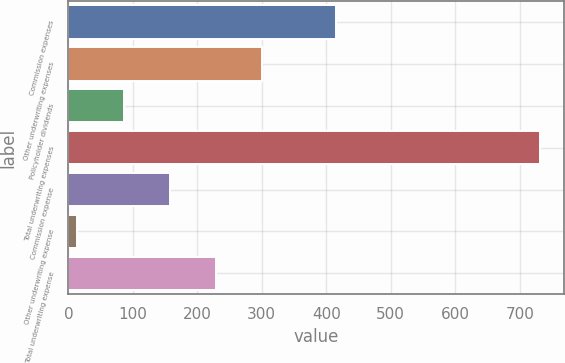Convert chart. <chart><loc_0><loc_0><loc_500><loc_500><bar_chart><fcel>Commission expenses<fcel>Other underwriting expenses<fcel>Policyholder dividends<fcel>Total underwriting expenses<fcel>Commission expense<fcel>Other underwriting expense<fcel>Total underwriting expense<nl><fcel>415<fcel>301.08<fcel>85.62<fcel>732<fcel>157.44<fcel>13.8<fcel>229.26<nl></chart> 